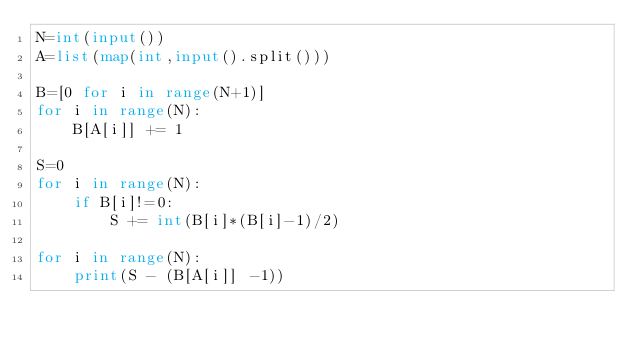<code> <loc_0><loc_0><loc_500><loc_500><_Python_>N=int(input())
A=list(map(int,input().split()))

B=[0 for i in range(N+1)]
for i in range(N):
    B[A[i]] += 1

S=0
for i in range(N):
    if B[i]!=0:
        S += int(B[i]*(B[i]-1)/2)

for i in range(N):
    print(S - (B[A[i]] -1))
    
    </code> 